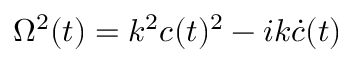<formula> <loc_0><loc_0><loc_500><loc_500>\Omega ^ { 2 } ( t ) = k ^ { 2 } c ( t ) ^ { 2 } - i k \dot { c } ( t )</formula> 